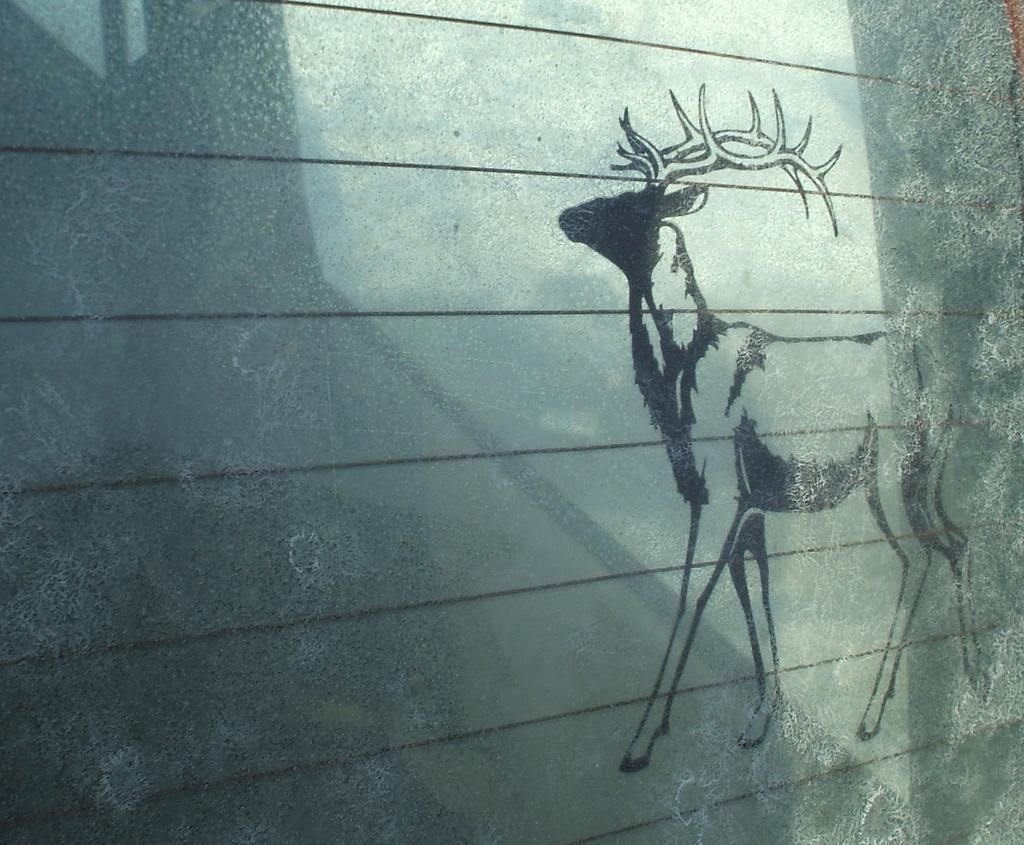What is present on the wall in the image? There is an art piece of a deer on the wall. Can you describe the art piece in more detail? Unfortunately, the provided facts do not offer more details about the art piece. What is the primary color of the art piece? The primary color of the art piece cannot be determined from the provided facts. Where is the key to the attraction located in the image? There is: There is no mention of a key or an attraction in the provided facts, so we cannot determine their location in the image. 